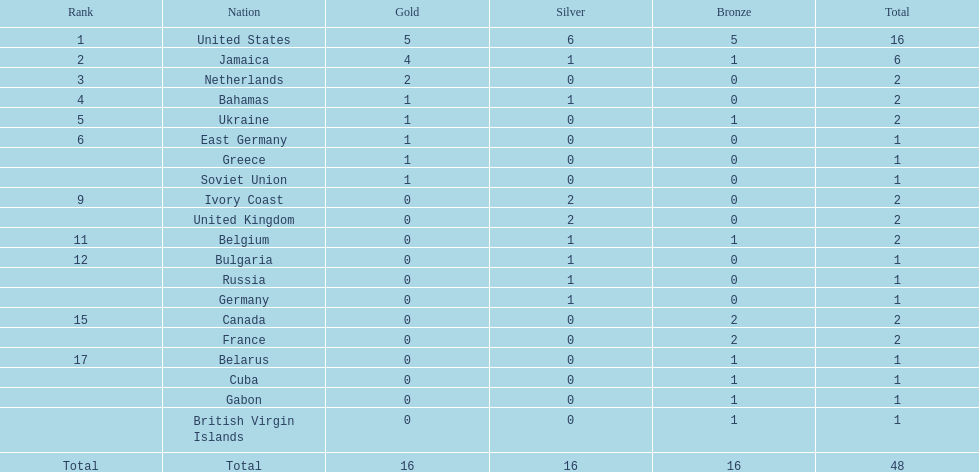What is the total number of gold medals won by the us and jamaica together? 9. 